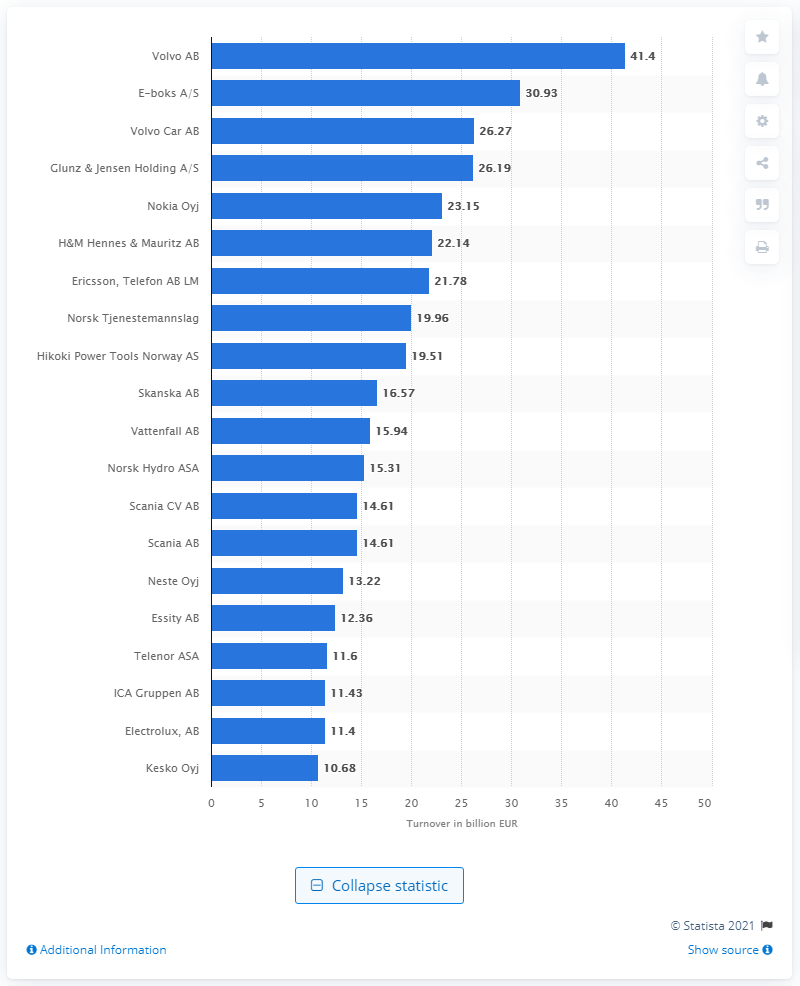Indicate a few pertinent items in this graphic. E-Boks had a turnover of 30.93 during the year. The turnover of Volvo in 2021 was 41.4 billion. 